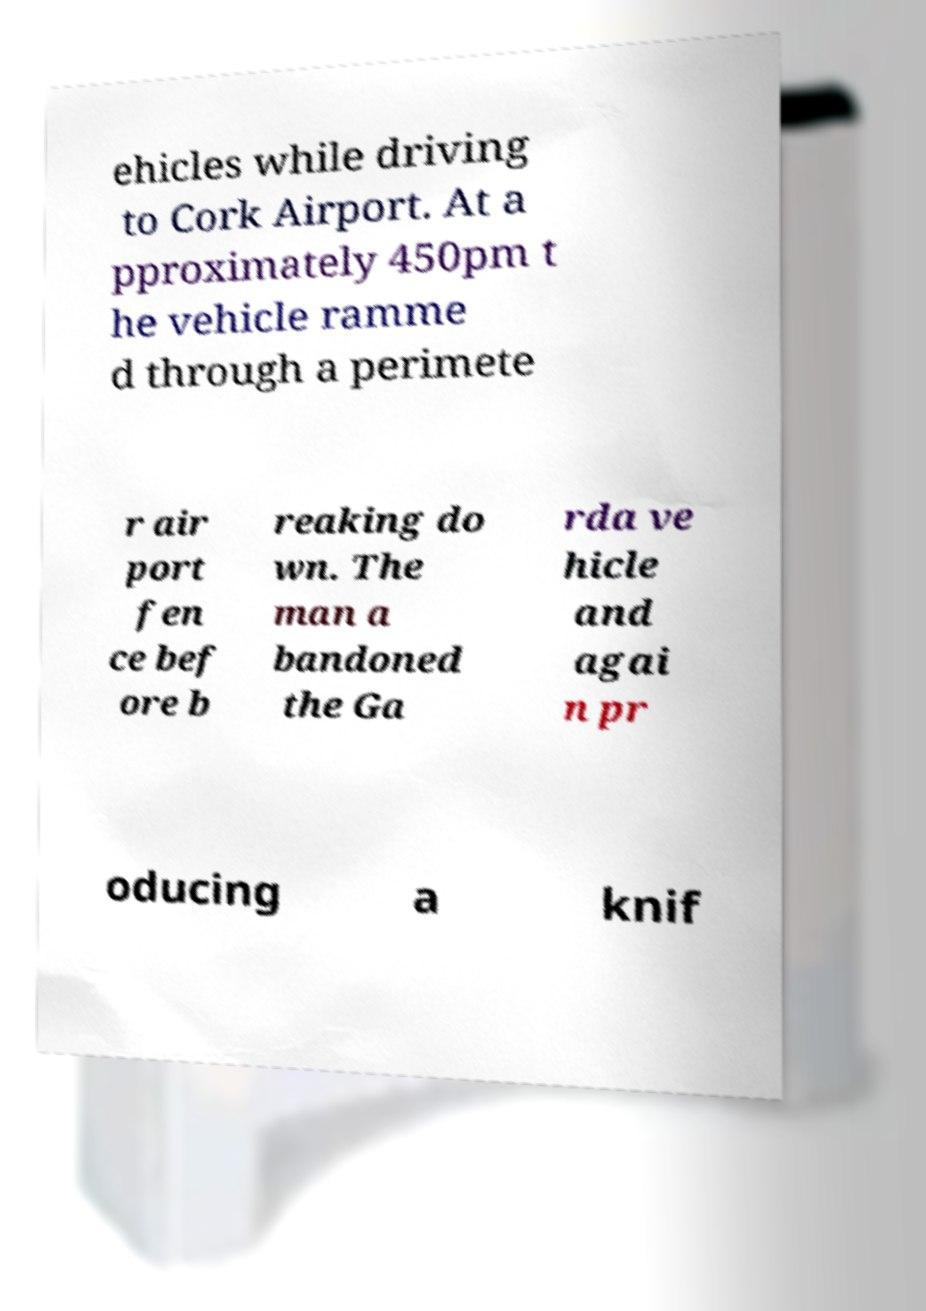Please read and relay the text visible in this image. What does it say? ehicles while driving to Cork Airport. At a pproximately 450pm t he vehicle ramme d through a perimete r air port fen ce bef ore b reaking do wn. The man a bandoned the Ga rda ve hicle and agai n pr oducing a knif 